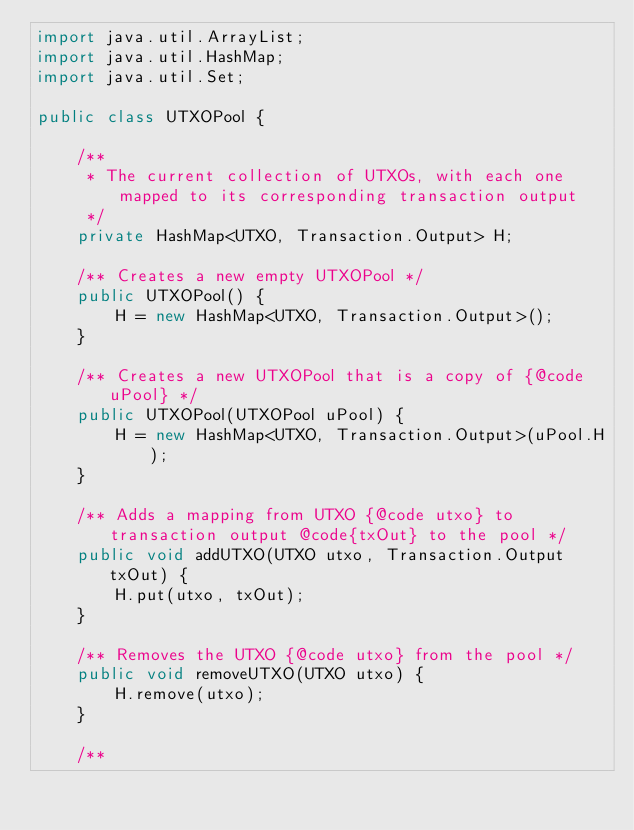Convert code to text. <code><loc_0><loc_0><loc_500><loc_500><_Java_>import java.util.ArrayList;
import java.util.HashMap;
import java.util.Set;

public class UTXOPool {

    /**
     * The current collection of UTXOs, with each one mapped to its corresponding transaction output
     */
    private HashMap<UTXO, Transaction.Output> H;

    /** Creates a new empty UTXOPool */
    public UTXOPool() {
        H = new HashMap<UTXO, Transaction.Output>();
    }

    /** Creates a new UTXOPool that is a copy of {@code uPool} */
    public UTXOPool(UTXOPool uPool) {
        H = new HashMap<UTXO, Transaction.Output>(uPool.H);
    }

    /** Adds a mapping from UTXO {@code utxo} to transaction output @code{txOut} to the pool */
    public void addUTXO(UTXO utxo, Transaction.Output txOut) {
        H.put(utxo, txOut);
    }

    /** Removes the UTXO {@code utxo} from the pool */
    public void removeUTXO(UTXO utxo) {
        H.remove(utxo);
    }

    /**</code> 